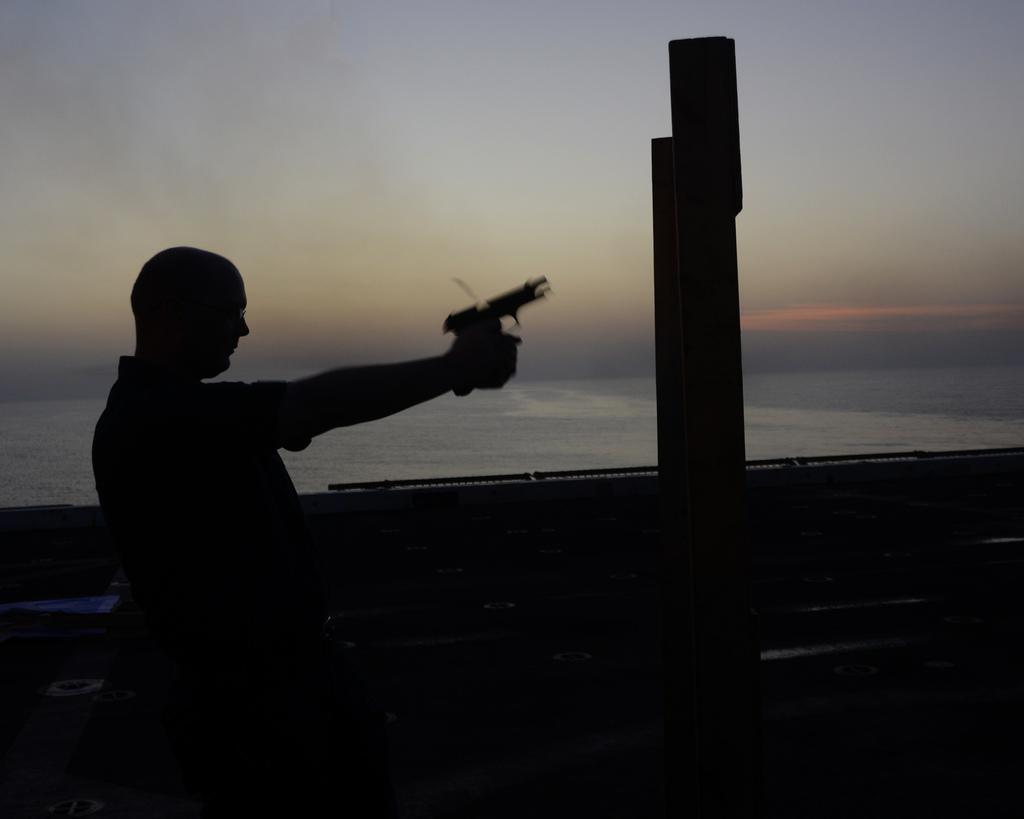Please provide a concise description of this image. There is a man holding a gun with his hand and there is a wall beside the man and behind the wall there is a sea. 